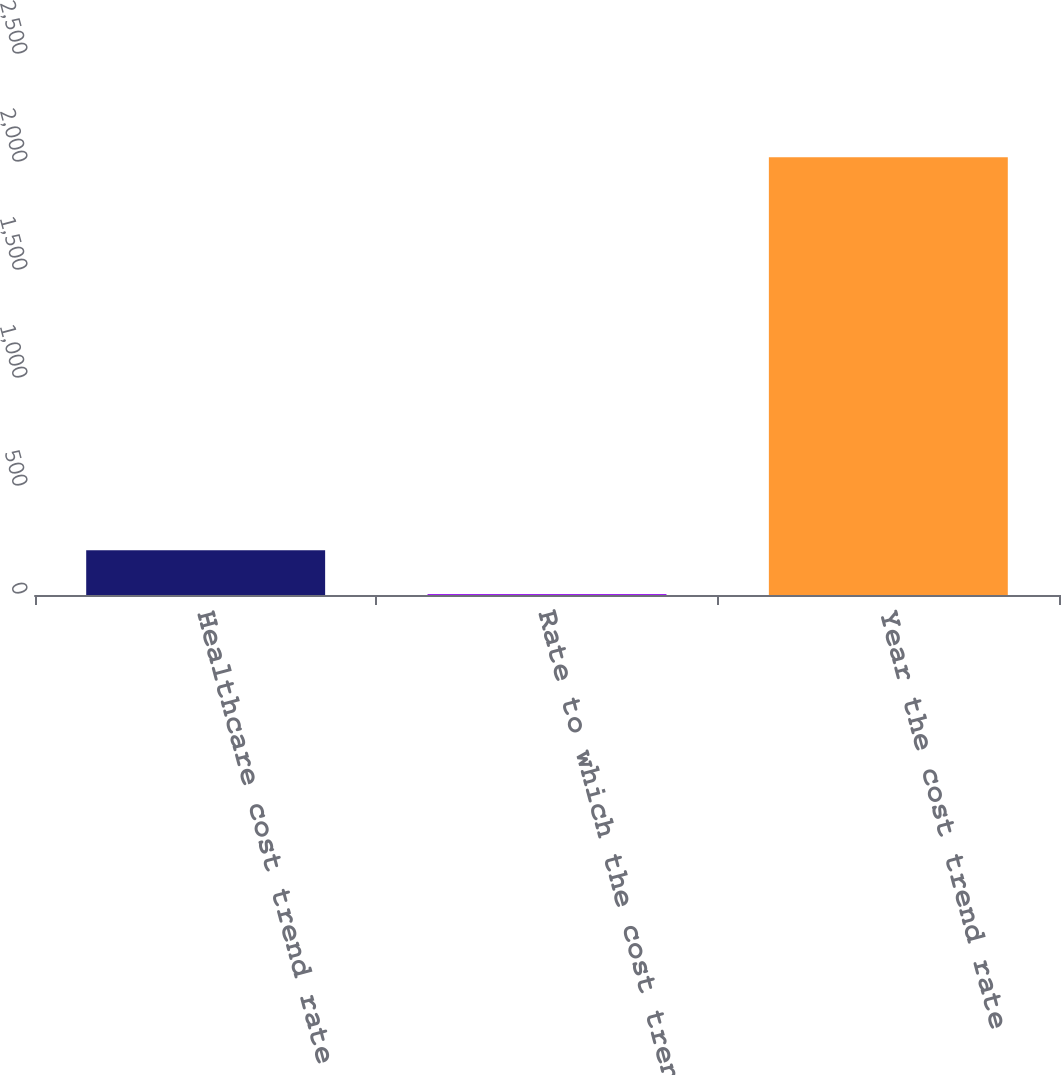Convert chart. <chart><loc_0><loc_0><loc_500><loc_500><bar_chart><fcel>Healthcare cost trend rate<fcel>Rate to which the cost trend<fcel>Year the cost trend rate<nl><fcel>206.75<fcel>4.5<fcel>2027<nl></chart> 